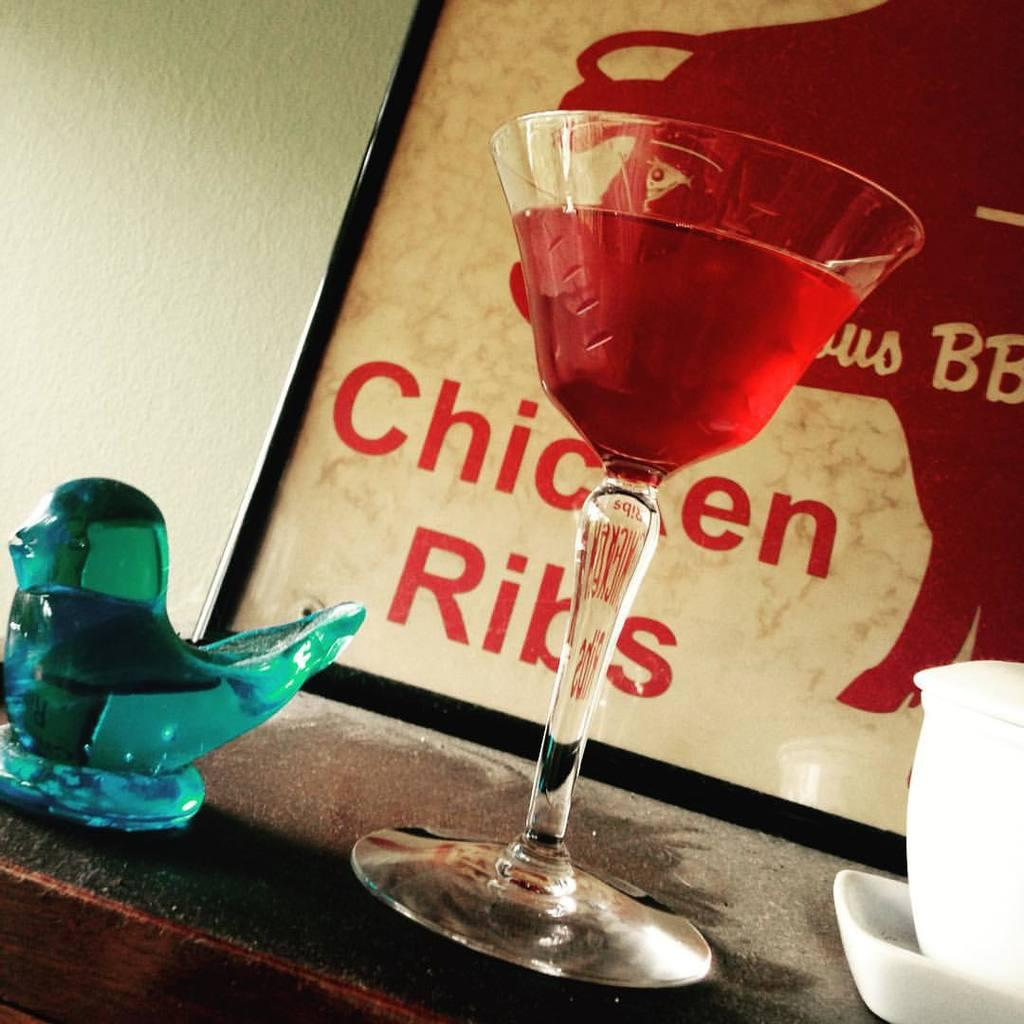What is in the glass that is visible in the image? There is a red liquid in the glass in the image. What color is the showpiece on the desk in the image? There is a blue showpiece on the desk in the image. What other items can be seen on the desk in the image? There is a bowl and a plate on the desk in the image. What is hanging on the wall in the image? A frame is visible on the wall in the image. What type of wood is used to make the sign in the image? There is no sign present in the image; it only features a glass with red liquid, a blue showpiece, a bowl, a plate, and a frame on the wall. 